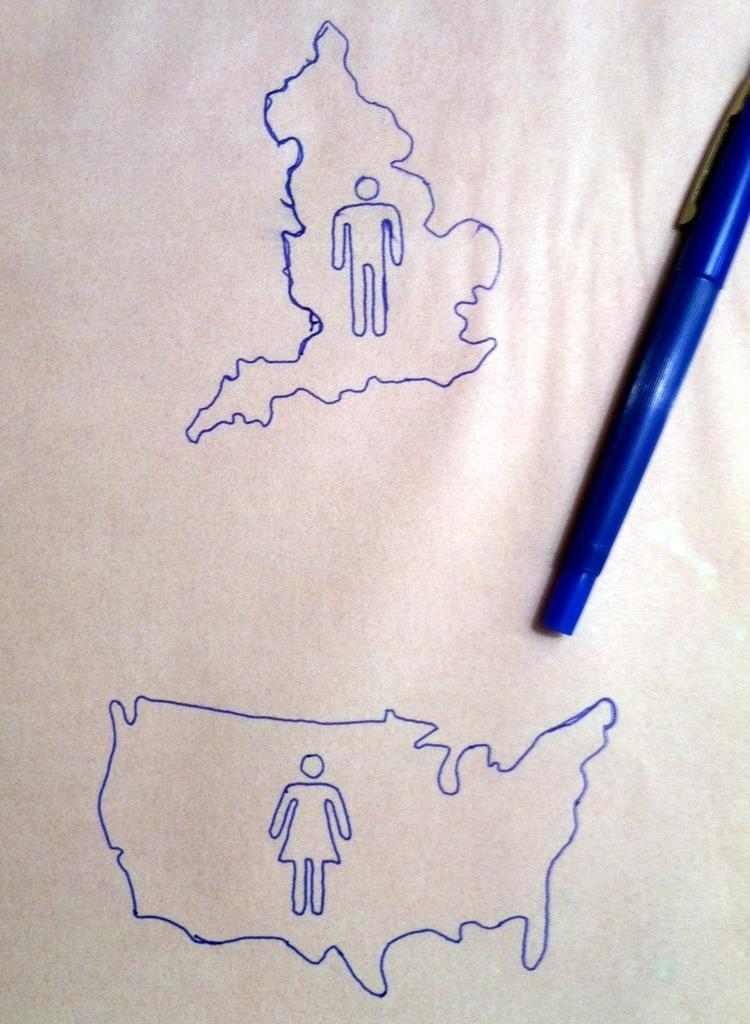Could you give a brief overview of what you see in this image? These are the 2 diagrams in blue color on a white paper, there is a pen on the right side of an image. 